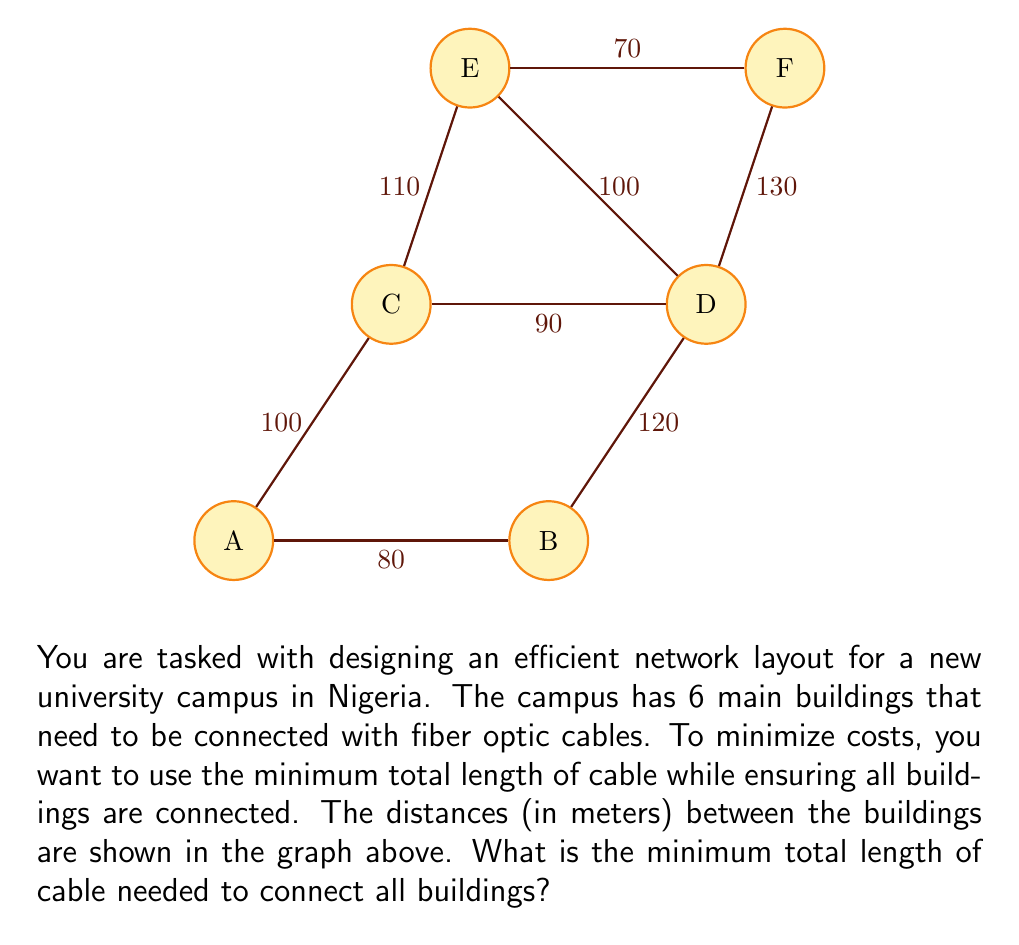Could you help me with this problem? To solve this problem, we need to find the minimum spanning tree (MST) of the given graph. The MST will connect all buildings with the minimum total cable length. We can use Kruskal's algorithm to find the MST:

1. Sort all edges by weight (distance) in ascending order:
   70m (E-F), 80m (A-B), 90m (C-D), 100m (A-C), 100m (D-E), 110m (C-E), 120m (B-D), 130m (D-F)

2. Start with an empty set of edges and add edges one by one, skipping any that would create a cycle:

   a. Add E-F (70m)
   b. Add A-B (80m)
   c. Add C-D (90m)
   d. Add A-C (100m)
   e. Skip D-E (100m) as it would create a cycle
   f. Skip C-E (110m) as it would create a cycle
   g. Skip B-D (120m) as it would create a cycle
   h. Skip D-F (130m) as it would create a cycle

3. The resulting MST consists of the following edges:
   E-F (70m), A-B (80m), C-D (90m), A-C (100m)

4. Calculate the total length of cable needed:
   $$70 + 80 + 90 + 100 = 340\text{ meters}$$

Therefore, the minimum total length of cable needed to connect all buildings is 340 meters.
Answer: 340 meters 